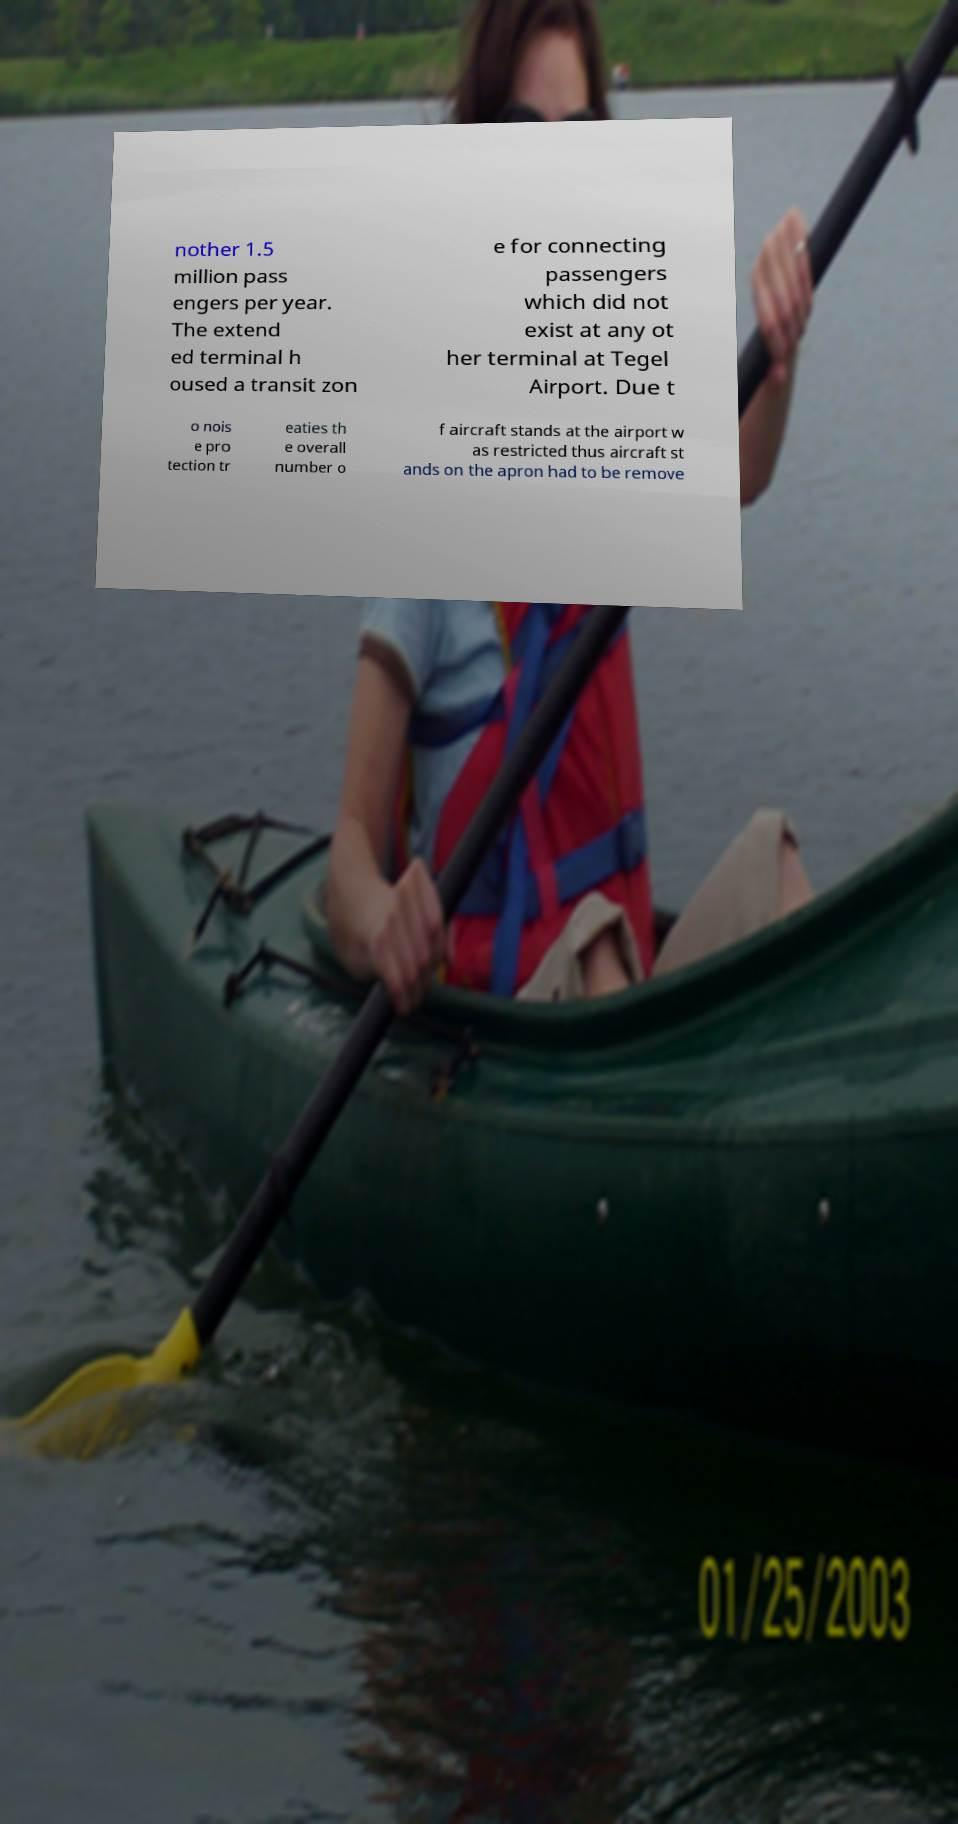Can you read and provide the text displayed in the image?This photo seems to have some interesting text. Can you extract and type it out for me? nother 1.5 million pass engers per year. The extend ed terminal h oused a transit zon e for connecting passengers which did not exist at any ot her terminal at Tegel Airport. Due t o nois e pro tection tr eaties th e overall number o f aircraft stands at the airport w as restricted thus aircraft st ands on the apron had to be remove 